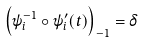<formula> <loc_0><loc_0><loc_500><loc_500>\left ( \psi _ { i } ^ { - 1 } \circ \psi _ { i } ^ { \prime } ( t ) \right ) _ { - 1 } = \delta</formula> 